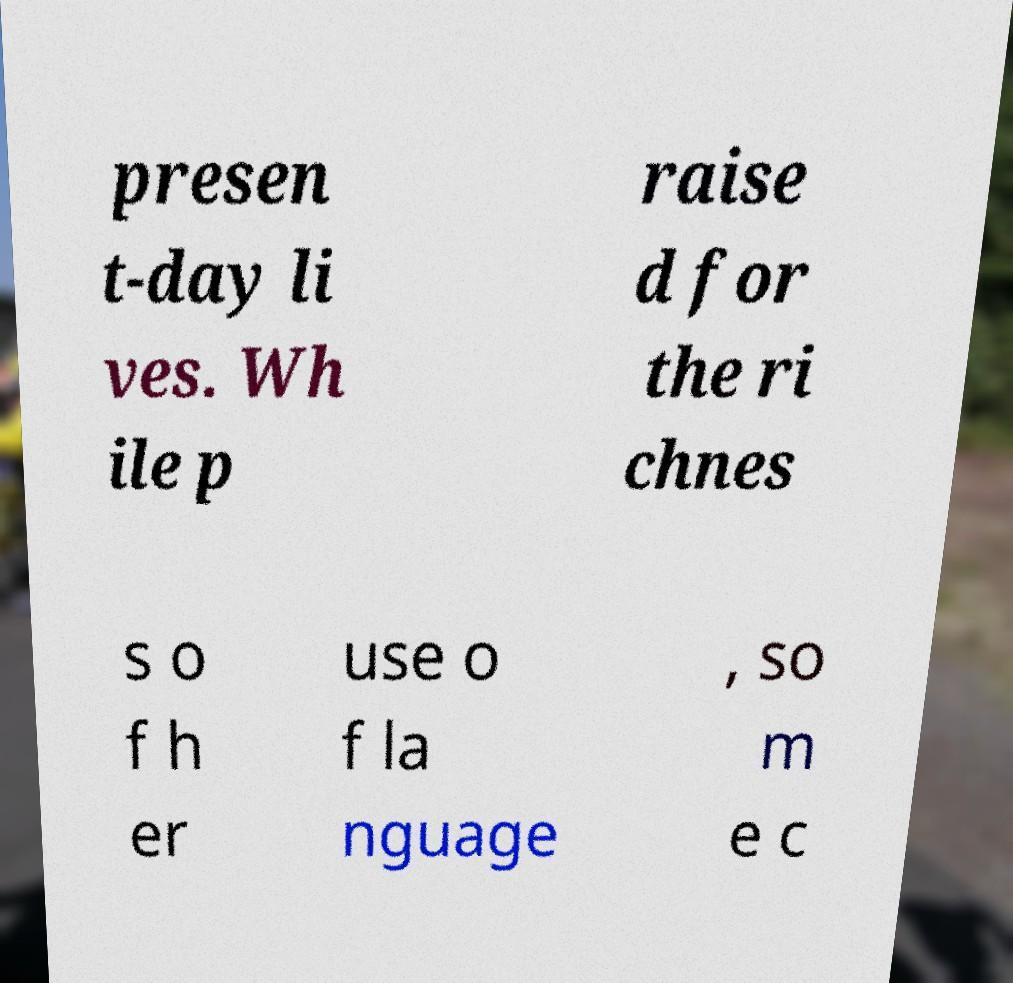Can you read and provide the text displayed in the image?This photo seems to have some interesting text. Can you extract and type it out for me? presen t-day li ves. Wh ile p raise d for the ri chnes s o f h er use o f la nguage , so m e c 